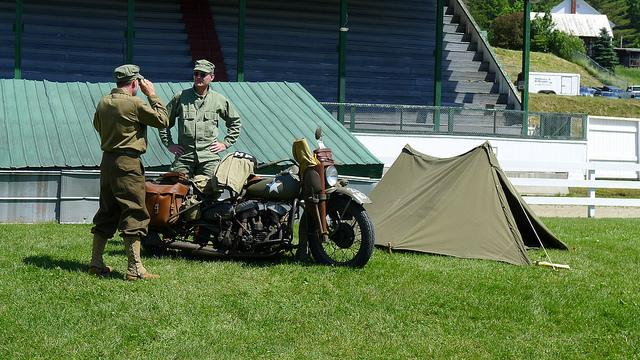Which one is the superior officer?

Choices:
A) can't tell
B) in trailer
C) facing camera
D) back turned facing camera 